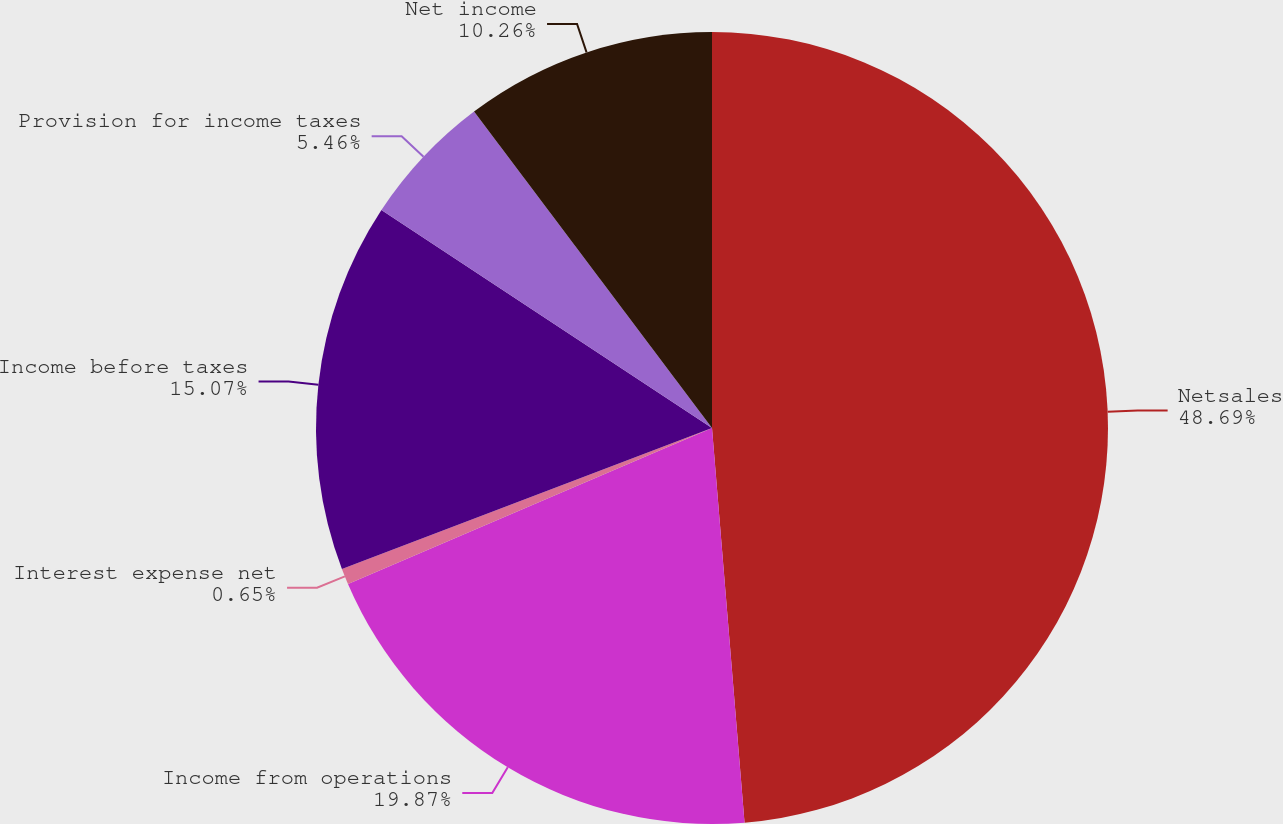Convert chart. <chart><loc_0><loc_0><loc_500><loc_500><pie_chart><fcel>Netsales<fcel>Income from operations<fcel>Interest expense net<fcel>Income before taxes<fcel>Provision for income taxes<fcel>Net income<nl><fcel>48.69%<fcel>19.87%<fcel>0.65%<fcel>15.07%<fcel>5.46%<fcel>10.26%<nl></chart> 